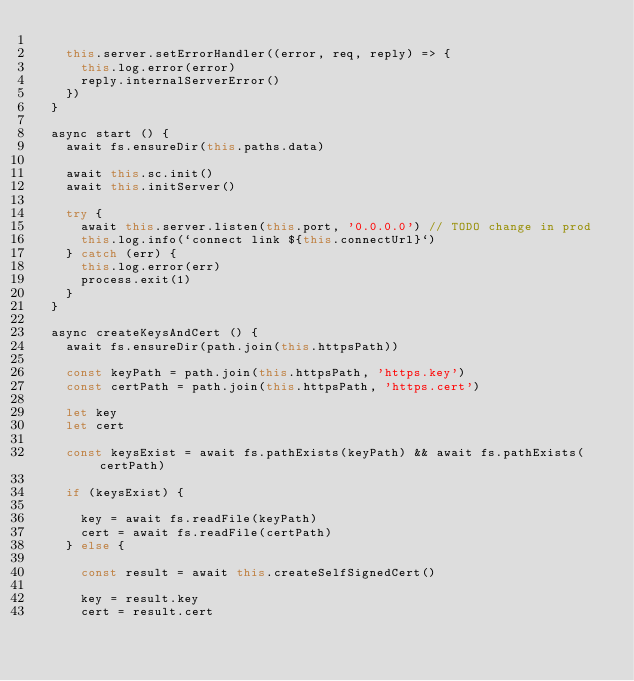Convert code to text. <code><loc_0><loc_0><loc_500><loc_500><_JavaScript_>
    this.server.setErrorHandler((error, req, reply) => {
      this.log.error(error)
      reply.internalServerError()
    })
  }

  async start () {
    await fs.ensureDir(this.paths.data)

    await this.sc.init()
    await this.initServer()

    try {
      await this.server.listen(this.port, '0.0.0.0') // TODO change in prod
      this.log.info(`connect link ${this.connectUrl}`)
    } catch (err) {
      this.log.error(err)
      process.exit(1)
    }
  }

  async createKeysAndCert () {
    await fs.ensureDir(path.join(this.httpsPath))

    const keyPath = path.join(this.httpsPath, 'https.key')
    const certPath = path.join(this.httpsPath, 'https.cert')

    let key
    let cert

    const keysExist = await fs.pathExists(keyPath) && await fs.pathExists(certPath)

    if (keysExist) {

      key = await fs.readFile(keyPath)
      cert = await fs.readFile(certPath)
    } else {

      const result = await this.createSelfSignedCert()

      key = result.key
      cert = result.cert
</code> 